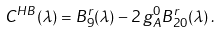Convert formula to latex. <formula><loc_0><loc_0><loc_500><loc_500>C ^ { H B } ( \lambda ) = B _ { 9 } ^ { r } ( \lambda ) - 2 \, g _ { A } ^ { 0 } B _ { 2 0 } ^ { r } ( \lambda ) \, .</formula> 